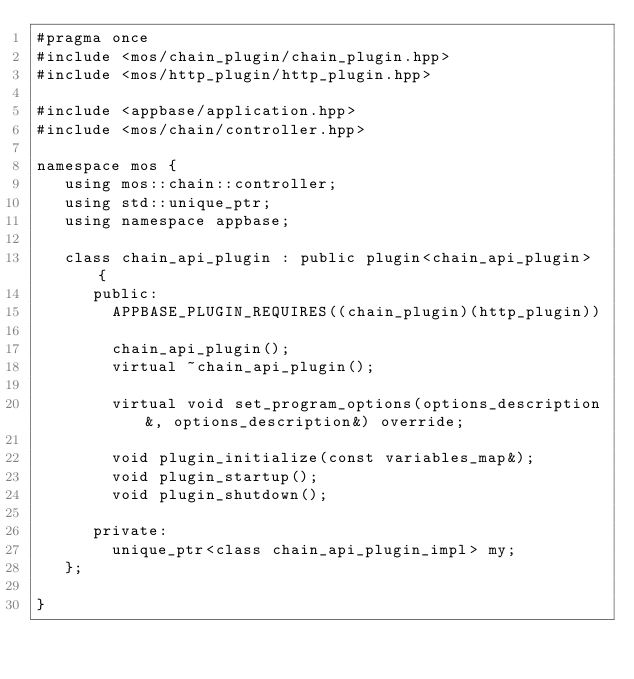<code> <loc_0><loc_0><loc_500><loc_500><_C++_>#pragma once
#include <mos/chain_plugin/chain_plugin.hpp>
#include <mos/http_plugin/http_plugin.hpp>

#include <appbase/application.hpp>
#include <mos/chain/controller.hpp>

namespace mos {
   using mos::chain::controller;
   using std::unique_ptr;
   using namespace appbase;

   class chain_api_plugin : public plugin<chain_api_plugin> {
      public:
        APPBASE_PLUGIN_REQUIRES((chain_plugin)(http_plugin))

        chain_api_plugin();
        virtual ~chain_api_plugin();

        virtual void set_program_options(options_description&, options_description&) override;

        void plugin_initialize(const variables_map&);
        void plugin_startup();
        void plugin_shutdown();

      private:
        unique_ptr<class chain_api_plugin_impl> my;
   };

}
</code> 